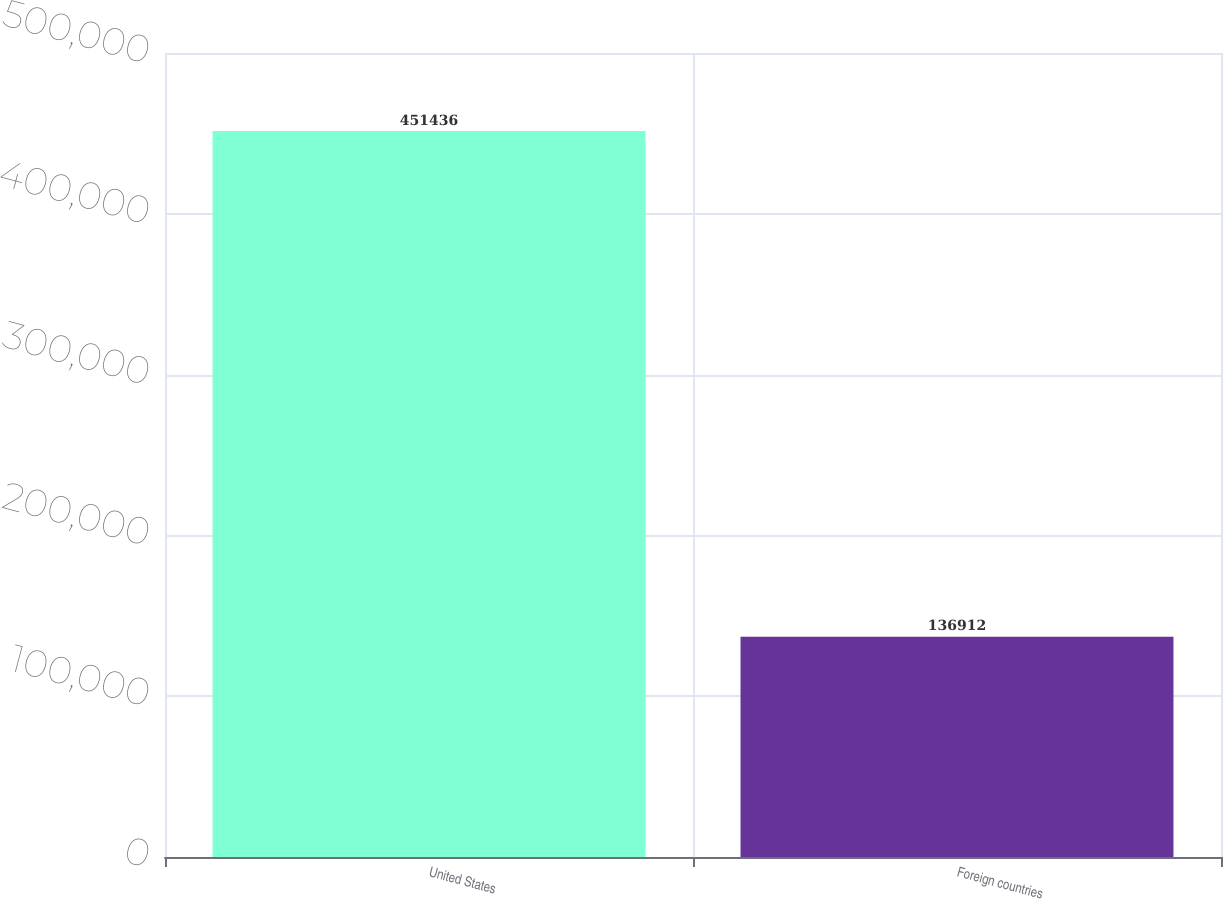<chart> <loc_0><loc_0><loc_500><loc_500><bar_chart><fcel>United States<fcel>Foreign countries<nl><fcel>451436<fcel>136912<nl></chart> 